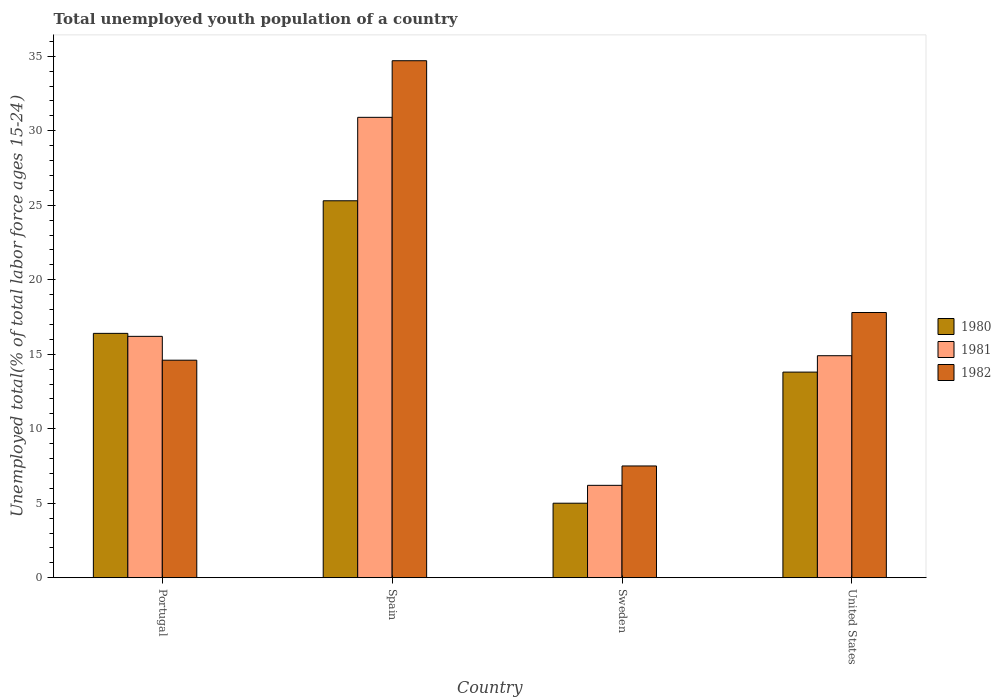How many groups of bars are there?
Your response must be concise. 4. Are the number of bars on each tick of the X-axis equal?
Make the answer very short. Yes. How many bars are there on the 1st tick from the left?
Your answer should be very brief. 3. How many bars are there on the 1st tick from the right?
Provide a succinct answer. 3. What is the percentage of total unemployed youth population of a country in 1980 in Sweden?
Your answer should be very brief. 5. Across all countries, what is the maximum percentage of total unemployed youth population of a country in 1982?
Your answer should be very brief. 34.7. Across all countries, what is the minimum percentage of total unemployed youth population of a country in 1981?
Make the answer very short. 6.2. In which country was the percentage of total unemployed youth population of a country in 1982 maximum?
Your response must be concise. Spain. What is the total percentage of total unemployed youth population of a country in 1981 in the graph?
Make the answer very short. 68.2. What is the difference between the percentage of total unemployed youth population of a country in 1980 in Spain and that in Sweden?
Your answer should be compact. 20.3. What is the difference between the percentage of total unemployed youth population of a country in 1981 in Spain and the percentage of total unemployed youth population of a country in 1980 in United States?
Keep it short and to the point. 17.1. What is the average percentage of total unemployed youth population of a country in 1981 per country?
Your response must be concise. 17.05. What is the difference between the percentage of total unemployed youth population of a country of/in 1981 and percentage of total unemployed youth population of a country of/in 1982 in United States?
Keep it short and to the point. -2.9. What is the ratio of the percentage of total unemployed youth population of a country in 1981 in Portugal to that in United States?
Your response must be concise. 1.09. Is the percentage of total unemployed youth population of a country in 1980 in Sweden less than that in United States?
Give a very brief answer. Yes. What is the difference between the highest and the second highest percentage of total unemployed youth population of a country in 1981?
Your answer should be compact. -14.7. What is the difference between the highest and the lowest percentage of total unemployed youth population of a country in 1980?
Your answer should be very brief. 20.3. Is the sum of the percentage of total unemployed youth population of a country in 1982 in Spain and United States greater than the maximum percentage of total unemployed youth population of a country in 1981 across all countries?
Provide a succinct answer. Yes. What does the 3rd bar from the left in Portugal represents?
Your response must be concise. 1982. How many bars are there?
Keep it short and to the point. 12. Are all the bars in the graph horizontal?
Your answer should be compact. No. Are the values on the major ticks of Y-axis written in scientific E-notation?
Provide a short and direct response. No. Does the graph contain any zero values?
Your response must be concise. No. Where does the legend appear in the graph?
Make the answer very short. Center right. How many legend labels are there?
Offer a terse response. 3. What is the title of the graph?
Give a very brief answer. Total unemployed youth population of a country. What is the label or title of the X-axis?
Give a very brief answer. Country. What is the label or title of the Y-axis?
Make the answer very short. Unemployed total(% of total labor force ages 15-24). What is the Unemployed total(% of total labor force ages 15-24) of 1980 in Portugal?
Provide a succinct answer. 16.4. What is the Unemployed total(% of total labor force ages 15-24) of 1981 in Portugal?
Make the answer very short. 16.2. What is the Unemployed total(% of total labor force ages 15-24) in 1982 in Portugal?
Give a very brief answer. 14.6. What is the Unemployed total(% of total labor force ages 15-24) in 1980 in Spain?
Your answer should be compact. 25.3. What is the Unemployed total(% of total labor force ages 15-24) in 1981 in Spain?
Your answer should be compact. 30.9. What is the Unemployed total(% of total labor force ages 15-24) in 1982 in Spain?
Ensure brevity in your answer.  34.7. What is the Unemployed total(% of total labor force ages 15-24) of 1980 in Sweden?
Offer a terse response. 5. What is the Unemployed total(% of total labor force ages 15-24) of 1981 in Sweden?
Offer a terse response. 6.2. What is the Unemployed total(% of total labor force ages 15-24) in 1980 in United States?
Offer a terse response. 13.8. What is the Unemployed total(% of total labor force ages 15-24) of 1981 in United States?
Your response must be concise. 14.9. What is the Unemployed total(% of total labor force ages 15-24) of 1982 in United States?
Your answer should be compact. 17.8. Across all countries, what is the maximum Unemployed total(% of total labor force ages 15-24) of 1980?
Keep it short and to the point. 25.3. Across all countries, what is the maximum Unemployed total(% of total labor force ages 15-24) of 1981?
Your response must be concise. 30.9. Across all countries, what is the maximum Unemployed total(% of total labor force ages 15-24) in 1982?
Offer a terse response. 34.7. Across all countries, what is the minimum Unemployed total(% of total labor force ages 15-24) of 1981?
Give a very brief answer. 6.2. What is the total Unemployed total(% of total labor force ages 15-24) of 1980 in the graph?
Ensure brevity in your answer.  60.5. What is the total Unemployed total(% of total labor force ages 15-24) of 1981 in the graph?
Ensure brevity in your answer.  68.2. What is the total Unemployed total(% of total labor force ages 15-24) in 1982 in the graph?
Offer a very short reply. 74.6. What is the difference between the Unemployed total(% of total labor force ages 15-24) in 1980 in Portugal and that in Spain?
Give a very brief answer. -8.9. What is the difference between the Unemployed total(% of total labor force ages 15-24) in 1981 in Portugal and that in Spain?
Offer a terse response. -14.7. What is the difference between the Unemployed total(% of total labor force ages 15-24) of 1982 in Portugal and that in Spain?
Your answer should be compact. -20.1. What is the difference between the Unemployed total(% of total labor force ages 15-24) of 1981 in Portugal and that in Sweden?
Ensure brevity in your answer.  10. What is the difference between the Unemployed total(% of total labor force ages 15-24) of 1980 in Portugal and that in United States?
Provide a short and direct response. 2.6. What is the difference between the Unemployed total(% of total labor force ages 15-24) of 1980 in Spain and that in Sweden?
Offer a very short reply. 20.3. What is the difference between the Unemployed total(% of total labor force ages 15-24) in 1981 in Spain and that in Sweden?
Your answer should be compact. 24.7. What is the difference between the Unemployed total(% of total labor force ages 15-24) in 1982 in Spain and that in Sweden?
Offer a very short reply. 27.2. What is the difference between the Unemployed total(% of total labor force ages 15-24) in 1981 in Sweden and that in United States?
Your answer should be very brief. -8.7. What is the difference between the Unemployed total(% of total labor force ages 15-24) in 1982 in Sweden and that in United States?
Keep it short and to the point. -10.3. What is the difference between the Unemployed total(% of total labor force ages 15-24) in 1980 in Portugal and the Unemployed total(% of total labor force ages 15-24) in 1981 in Spain?
Offer a terse response. -14.5. What is the difference between the Unemployed total(% of total labor force ages 15-24) in 1980 in Portugal and the Unemployed total(% of total labor force ages 15-24) in 1982 in Spain?
Your answer should be very brief. -18.3. What is the difference between the Unemployed total(% of total labor force ages 15-24) of 1981 in Portugal and the Unemployed total(% of total labor force ages 15-24) of 1982 in Spain?
Your answer should be very brief. -18.5. What is the difference between the Unemployed total(% of total labor force ages 15-24) in 1980 in Portugal and the Unemployed total(% of total labor force ages 15-24) in 1981 in Sweden?
Your answer should be very brief. 10.2. What is the difference between the Unemployed total(% of total labor force ages 15-24) of 1980 in Portugal and the Unemployed total(% of total labor force ages 15-24) of 1982 in Sweden?
Your response must be concise. 8.9. What is the difference between the Unemployed total(% of total labor force ages 15-24) of 1980 in Portugal and the Unemployed total(% of total labor force ages 15-24) of 1982 in United States?
Your answer should be compact. -1.4. What is the difference between the Unemployed total(% of total labor force ages 15-24) of 1981 in Portugal and the Unemployed total(% of total labor force ages 15-24) of 1982 in United States?
Provide a succinct answer. -1.6. What is the difference between the Unemployed total(% of total labor force ages 15-24) in 1981 in Spain and the Unemployed total(% of total labor force ages 15-24) in 1982 in Sweden?
Your answer should be very brief. 23.4. What is the difference between the Unemployed total(% of total labor force ages 15-24) in 1980 in Spain and the Unemployed total(% of total labor force ages 15-24) in 1981 in United States?
Offer a very short reply. 10.4. What is the difference between the Unemployed total(% of total labor force ages 15-24) in 1981 in Spain and the Unemployed total(% of total labor force ages 15-24) in 1982 in United States?
Provide a short and direct response. 13.1. What is the difference between the Unemployed total(% of total labor force ages 15-24) of 1980 in Sweden and the Unemployed total(% of total labor force ages 15-24) of 1982 in United States?
Give a very brief answer. -12.8. What is the difference between the Unemployed total(% of total labor force ages 15-24) of 1981 in Sweden and the Unemployed total(% of total labor force ages 15-24) of 1982 in United States?
Your answer should be compact. -11.6. What is the average Unemployed total(% of total labor force ages 15-24) in 1980 per country?
Provide a short and direct response. 15.12. What is the average Unemployed total(% of total labor force ages 15-24) of 1981 per country?
Make the answer very short. 17.05. What is the average Unemployed total(% of total labor force ages 15-24) in 1982 per country?
Provide a short and direct response. 18.65. What is the difference between the Unemployed total(% of total labor force ages 15-24) in 1980 and Unemployed total(% of total labor force ages 15-24) in 1981 in Portugal?
Provide a succinct answer. 0.2. What is the difference between the Unemployed total(% of total labor force ages 15-24) of 1980 and Unemployed total(% of total labor force ages 15-24) of 1982 in Portugal?
Offer a very short reply. 1.8. What is the difference between the Unemployed total(% of total labor force ages 15-24) in 1981 and Unemployed total(% of total labor force ages 15-24) in 1982 in Portugal?
Offer a very short reply. 1.6. What is the difference between the Unemployed total(% of total labor force ages 15-24) in 1981 and Unemployed total(% of total labor force ages 15-24) in 1982 in Spain?
Your answer should be very brief. -3.8. What is the difference between the Unemployed total(% of total labor force ages 15-24) of 1980 and Unemployed total(% of total labor force ages 15-24) of 1981 in United States?
Provide a succinct answer. -1.1. What is the ratio of the Unemployed total(% of total labor force ages 15-24) of 1980 in Portugal to that in Spain?
Offer a very short reply. 0.65. What is the ratio of the Unemployed total(% of total labor force ages 15-24) of 1981 in Portugal to that in Spain?
Your response must be concise. 0.52. What is the ratio of the Unemployed total(% of total labor force ages 15-24) in 1982 in Portugal to that in Spain?
Give a very brief answer. 0.42. What is the ratio of the Unemployed total(% of total labor force ages 15-24) of 1980 in Portugal to that in Sweden?
Provide a succinct answer. 3.28. What is the ratio of the Unemployed total(% of total labor force ages 15-24) in 1981 in Portugal to that in Sweden?
Your response must be concise. 2.61. What is the ratio of the Unemployed total(% of total labor force ages 15-24) of 1982 in Portugal to that in Sweden?
Provide a succinct answer. 1.95. What is the ratio of the Unemployed total(% of total labor force ages 15-24) in 1980 in Portugal to that in United States?
Provide a succinct answer. 1.19. What is the ratio of the Unemployed total(% of total labor force ages 15-24) in 1981 in Portugal to that in United States?
Your response must be concise. 1.09. What is the ratio of the Unemployed total(% of total labor force ages 15-24) of 1982 in Portugal to that in United States?
Offer a very short reply. 0.82. What is the ratio of the Unemployed total(% of total labor force ages 15-24) in 1980 in Spain to that in Sweden?
Ensure brevity in your answer.  5.06. What is the ratio of the Unemployed total(% of total labor force ages 15-24) of 1981 in Spain to that in Sweden?
Ensure brevity in your answer.  4.98. What is the ratio of the Unemployed total(% of total labor force ages 15-24) of 1982 in Spain to that in Sweden?
Your answer should be compact. 4.63. What is the ratio of the Unemployed total(% of total labor force ages 15-24) in 1980 in Spain to that in United States?
Keep it short and to the point. 1.83. What is the ratio of the Unemployed total(% of total labor force ages 15-24) of 1981 in Spain to that in United States?
Your answer should be very brief. 2.07. What is the ratio of the Unemployed total(% of total labor force ages 15-24) of 1982 in Spain to that in United States?
Your response must be concise. 1.95. What is the ratio of the Unemployed total(% of total labor force ages 15-24) of 1980 in Sweden to that in United States?
Keep it short and to the point. 0.36. What is the ratio of the Unemployed total(% of total labor force ages 15-24) of 1981 in Sweden to that in United States?
Make the answer very short. 0.42. What is the ratio of the Unemployed total(% of total labor force ages 15-24) of 1982 in Sweden to that in United States?
Your response must be concise. 0.42. What is the difference between the highest and the second highest Unemployed total(% of total labor force ages 15-24) of 1980?
Provide a succinct answer. 8.9. What is the difference between the highest and the second highest Unemployed total(% of total labor force ages 15-24) of 1981?
Provide a succinct answer. 14.7. What is the difference between the highest and the second highest Unemployed total(% of total labor force ages 15-24) in 1982?
Make the answer very short. 16.9. What is the difference between the highest and the lowest Unemployed total(% of total labor force ages 15-24) of 1980?
Offer a very short reply. 20.3. What is the difference between the highest and the lowest Unemployed total(% of total labor force ages 15-24) of 1981?
Offer a very short reply. 24.7. What is the difference between the highest and the lowest Unemployed total(% of total labor force ages 15-24) of 1982?
Offer a terse response. 27.2. 